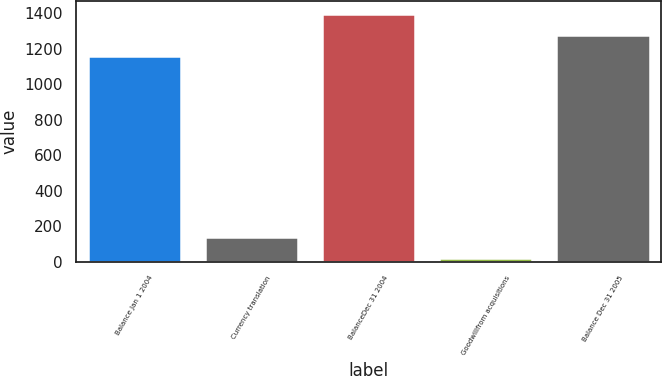Convert chart. <chart><loc_0><loc_0><loc_500><loc_500><bar_chart><fcel>Balance Jan 1 2004<fcel>Currency translation<fcel>BalanceDec 31 2004<fcel>Goodwillfrom acquisitions<fcel>Balance Dec 31 2005<nl><fcel>1157<fcel>140.5<fcel>1396<fcel>21<fcel>1276.5<nl></chart> 